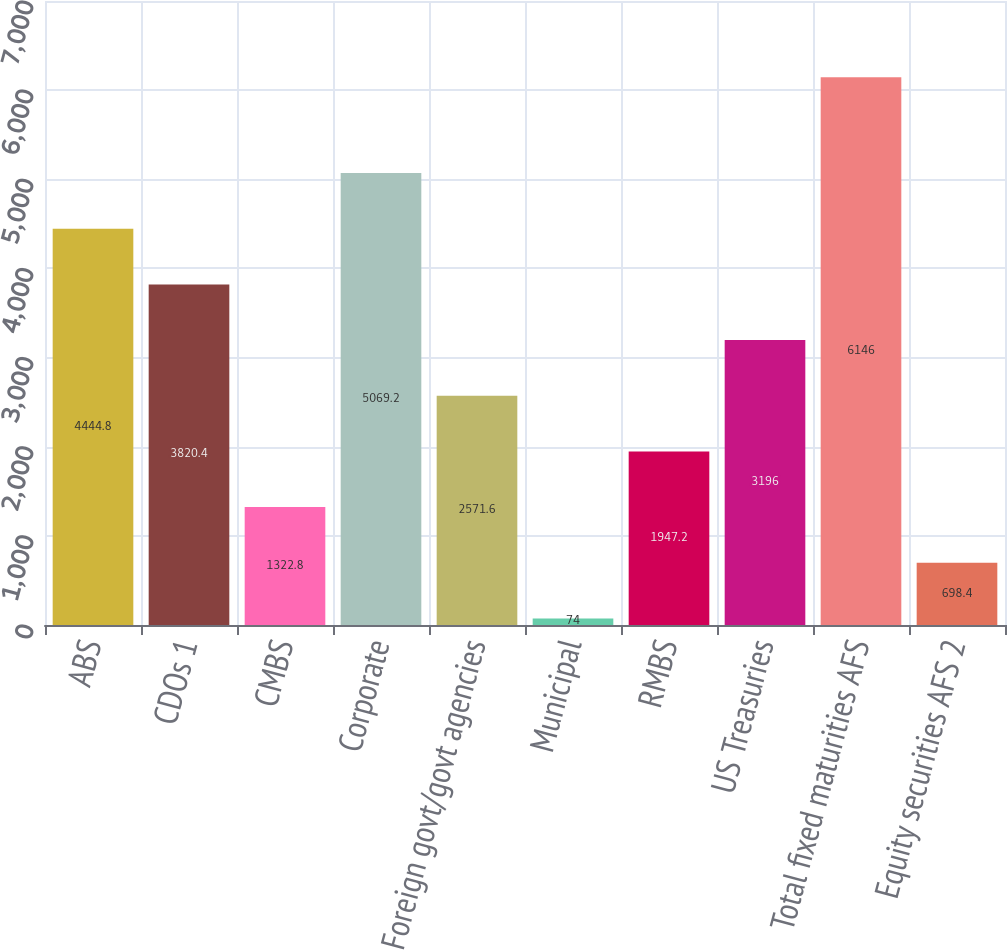Convert chart. <chart><loc_0><loc_0><loc_500><loc_500><bar_chart><fcel>ABS<fcel>CDOs 1<fcel>CMBS<fcel>Corporate<fcel>Foreign govt/govt agencies<fcel>Municipal<fcel>RMBS<fcel>US Treasuries<fcel>Total fixed maturities AFS<fcel>Equity securities AFS 2<nl><fcel>4444.8<fcel>3820.4<fcel>1322.8<fcel>5069.2<fcel>2571.6<fcel>74<fcel>1947.2<fcel>3196<fcel>6146<fcel>698.4<nl></chart> 